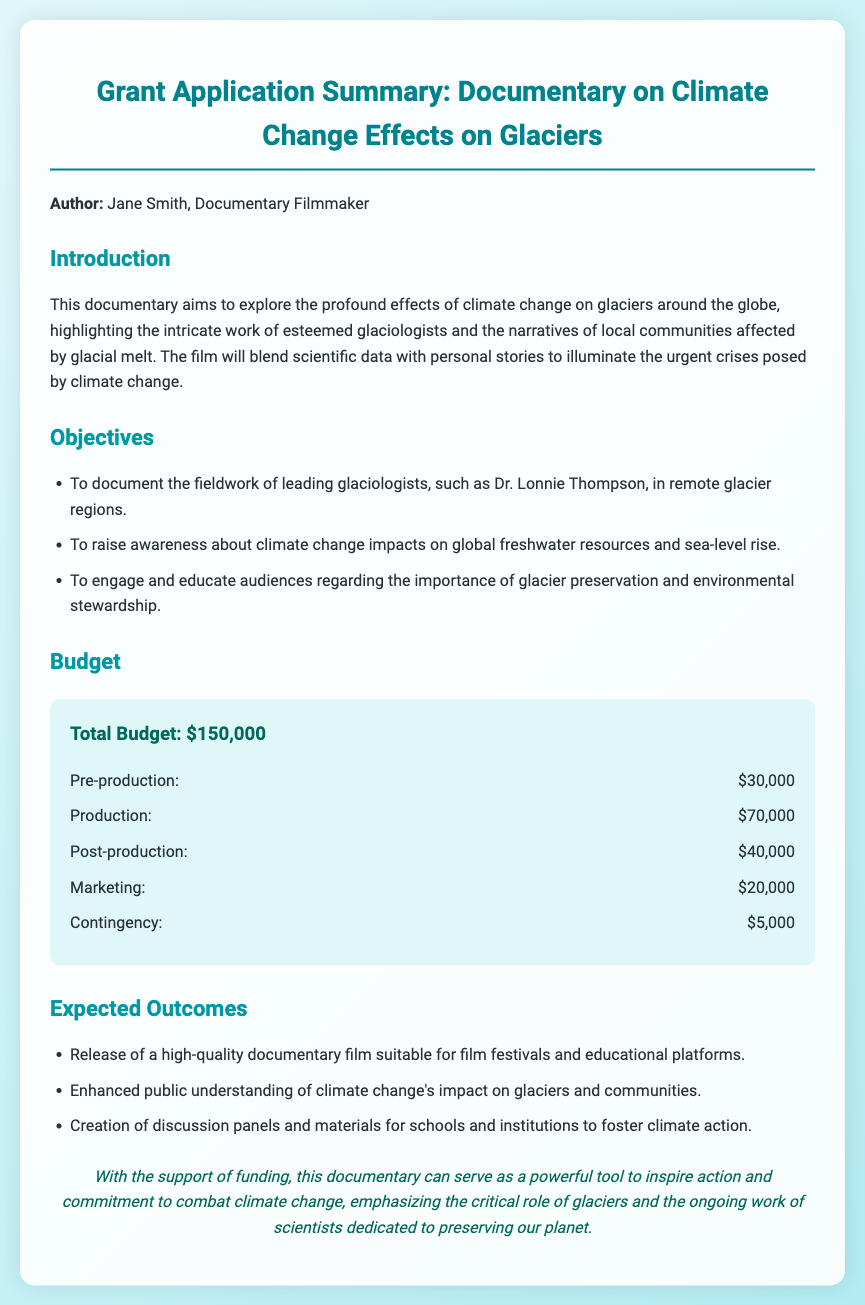What is the total budget for the documentary? The total budget is listed clearly in the budget section of the document as $150,000.
Answer: $150,000 Who is the author of the grant application? The author is mentioned at the beginning of the document as Jane Smith.
Answer: Jane Smith What is one objective of the documentary? The objectives are listed in a bullet format, and one of them is to raise awareness about climate change impacts on global freshwater resources and sea-level rise.
Answer: To raise awareness about climate change impacts on global freshwater resources and sea-level rise How much is allocated for production? The budget section specifies that $70,000 is allocated for production.
Answer: $70,000 What type of film will be released? The expected outcomes section mentions that a high-quality documentary film suitable for film festivals and educational platforms will be released.
Answer: A high-quality documentary film suitable for film festivals and educational platforms Which leading glaciologist is mentioned in the objectives? The document names Dr. Lonnie Thompson as a leading glaciologist whose work will be documented.
Answer: Dr. Lonnie Thompson What is one expected outcome of the documentary? The expected outcomes include enhanced public understanding of climate change's impact on glaciers and communities.
Answer: Enhanced public understanding of climate change's impact on glaciers and communities 